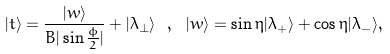Convert formula to latex. <formula><loc_0><loc_0><loc_500><loc_500>| t \rangle = \frac { | w \rangle } { B | \sin \frac { \phi } { 2 } | } + | \lambda _ { \perp } \rangle \ , \ | w \rangle = \sin \eta | \lambda _ { + } \rangle + \cos \eta | \lambda _ { - } \rangle ,</formula> 